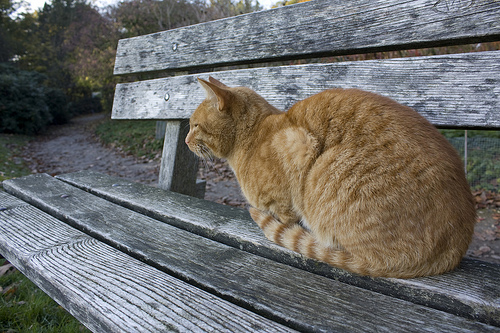Is the bench above the grass metallic and gray? No, the bench above the grass is not metallic and gray; it is wooden. 